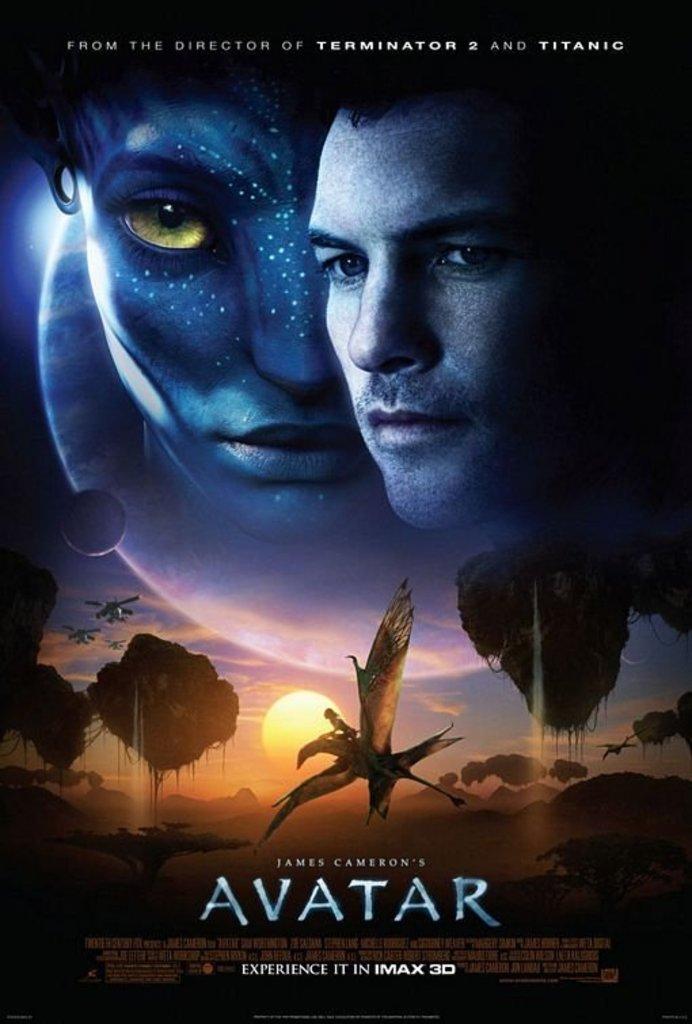Who directed this movie?
Make the answer very short. James cameron. 